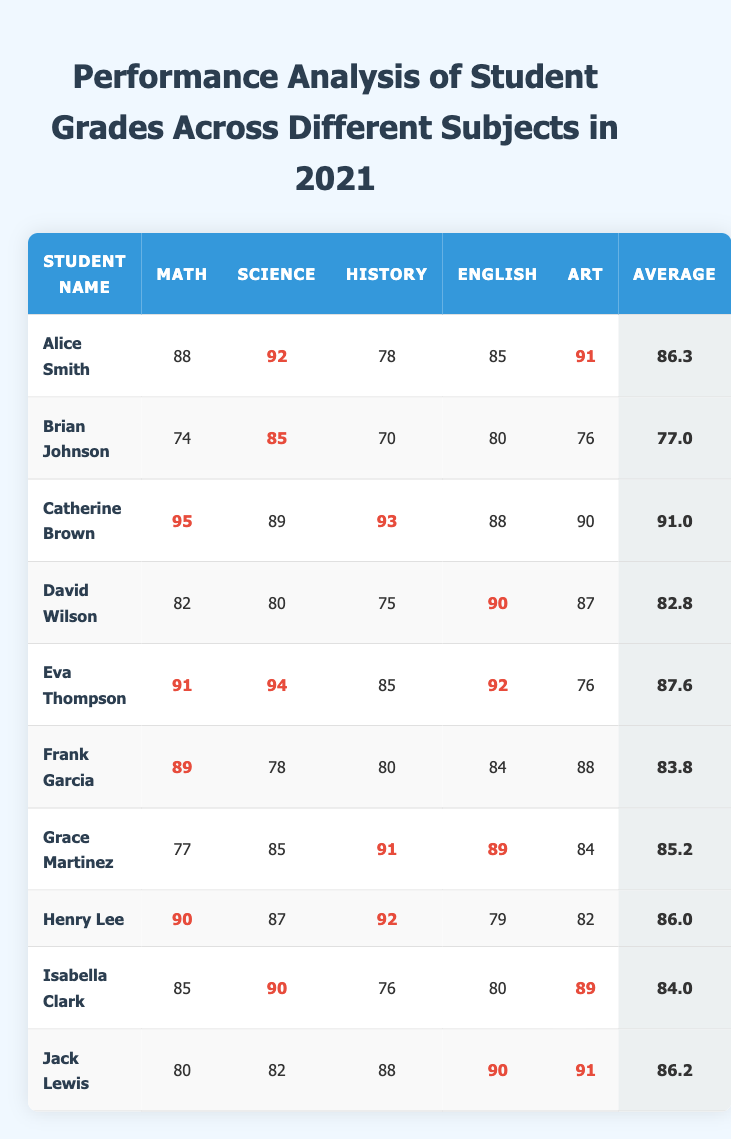What was Catherine Brown's highest score? Catherine Brown's highest scores can be found by looking at each subject's values. Math has 95, Science has 89, History has 93, English has 88, and Art has 90. The highest score is therefore 95 in Math.
Answer: 95 Which student had the lowest average grade? The average grades for each student are listed in the last column. Comparing all the averages, Brian Johnson has the lowest average at 77.0.
Answer: 77.0 Does Eva Thompson have a higher Science score than Jack Lewis? Eva Thompson's Science score is 94, while Jack Lewis's Science score is 82. Comparing these two values shows that 94 is greater than 82. Therefore, Eva Thompson has a higher Science score than Jack Lewis.
Answer: Yes Who scored the highest in Art? The Art scores can be checked by reviewing the Art column, where the highest value is found by comparing each student's score. The highest score of 91 belongs to both Alice Smith and Jack Lewis.
Answer: Alice Smith and Jack Lewis What is the average score of all students in History? To find the average score in History, we first sum the scores: 78 + 70 + 93 + 75 + 85 + 80 + 91 + 92 + 76 + 88 = 828. There are 10 students, so we divide the total by 10, which gives us 828 / 10 = 82.8.
Answer: 82.8 Which student has the highest average score? To determine this, we check the average column. The highest average is found with Catherine Brown at 91.0, as it is the largest value in that column.
Answer: 91.0 Is there a student who scored 90 or above in all subjects? We review the scores for each student to see if any student has scores of 90 or higher in every subject. A close examination reveals that there is no student whose scores are all 90 or above.
Answer: No How many students scored above 85 in Mathematics? By reviewing the Math column and counting the scores above 85, we find the scores of Alice Smith (88), Catherine Brown (95), Eva Thompson (91), Frank Garcia (89), and Henry Lee (90). This gives a total of 5 students.
Answer: 5 What is the difference between the highest and lowest average scores? The highest average score is Catherine Brown's 91.0, and the lowest is Brian Johnson's 77.0. The difference is calculated as 91.0 - 77.0 = 14.0.
Answer: 14.0 What percentage of students scored above 90 in Art? We check the Art scores, finding Alice Smith (91) and Jack Lewis (91) score above 90, while there are 10 students total. The percentage is (2/10)*100, equaling 20%.
Answer: 20% What is the combined score of David Wilson in Math and Science? To find David Wilson's combined score in Math and Science, we look at his Math score (82) and Science score (80). Adding these together gives 82 + 80 = 162.
Answer: 162 